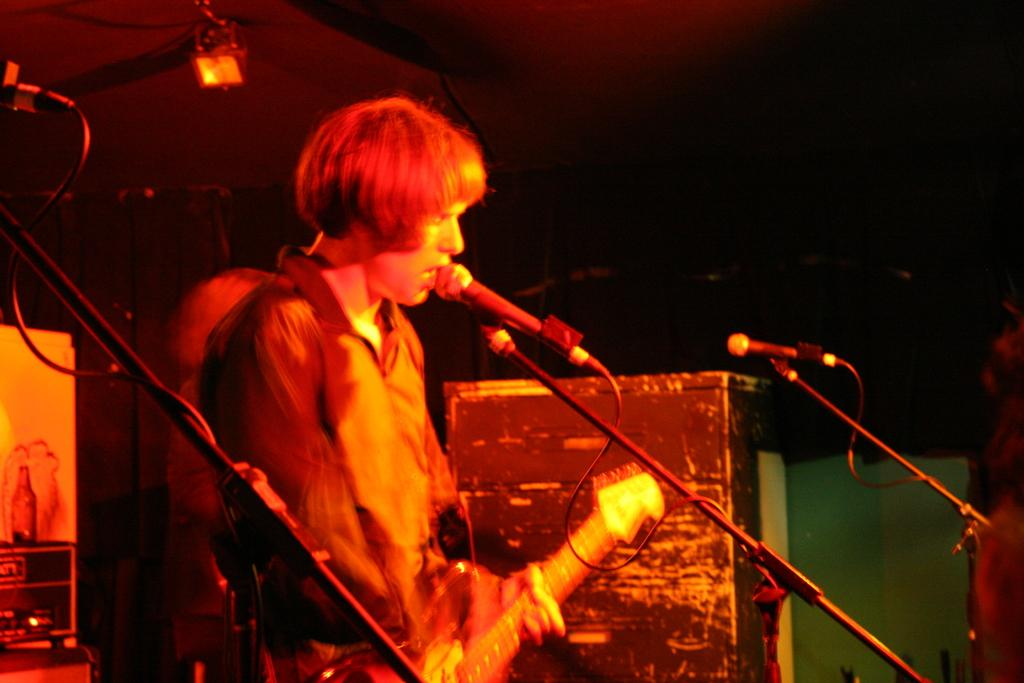What is the man in the image doing? The man is playing a guitar in the image. What object is in front of the man? There is a microphone in front of the man. What can be seen in the background of the image? There are lights visible in the background of the image. What type of government is depicted in the image? There is no depiction of a government in the image; it features a man playing a guitar with a microphone in front of him and lights in the background. 